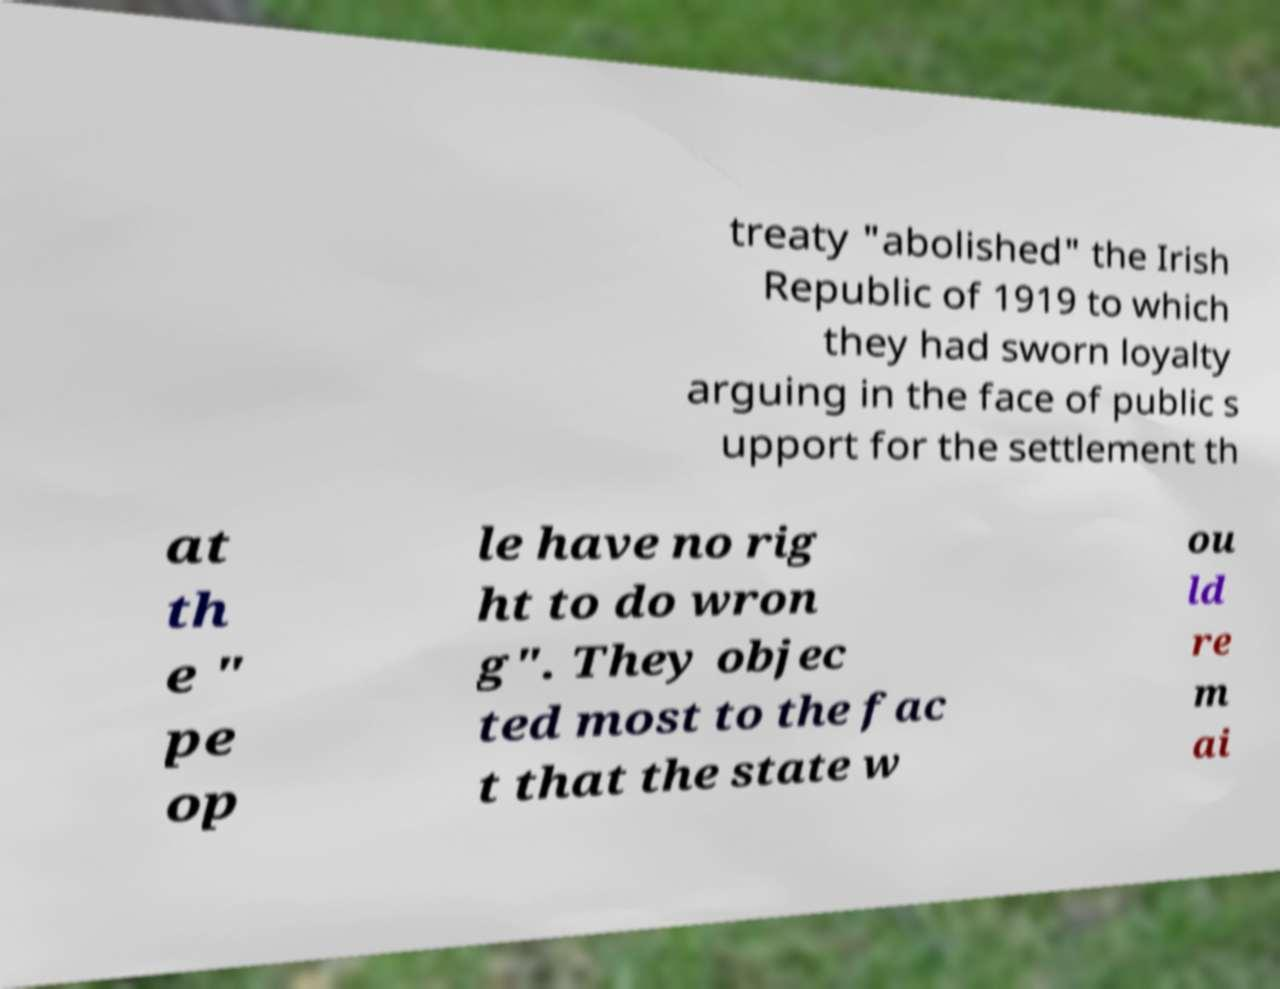What messages or text are displayed in this image? I need them in a readable, typed format. treaty "abolished" the Irish Republic of 1919 to which they had sworn loyalty arguing in the face of public s upport for the settlement th at th e " pe op le have no rig ht to do wron g". They objec ted most to the fac t that the state w ou ld re m ai 